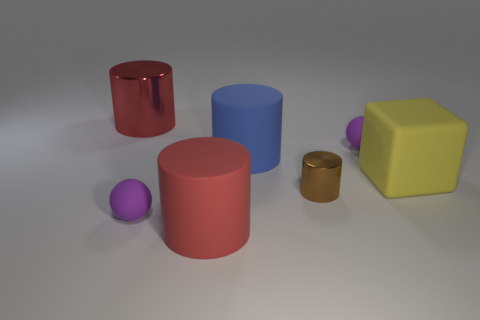Add 1 large rubber cubes. How many objects exist? 8 Subtract all cylinders. How many objects are left? 3 Subtract 0 red cubes. How many objects are left? 7 Subtract all yellow matte blocks. Subtract all purple things. How many objects are left? 4 Add 6 red cylinders. How many red cylinders are left? 8 Add 3 red cylinders. How many red cylinders exist? 5 